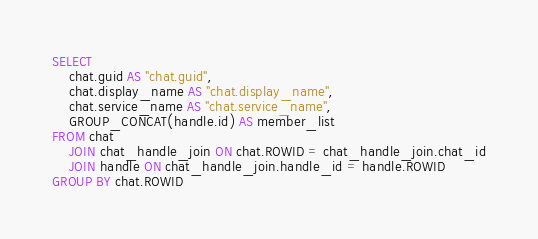Convert code to text. <code><loc_0><loc_0><loc_500><loc_500><_SQL_>SELECT
	chat.guid AS "chat.guid",
	chat.display_name AS "chat.display_name",
	chat.service_name AS "chat.service_name",
	GROUP_CONCAT(handle.id) AS member_list
FROM chat
	JOIN chat_handle_join ON chat.ROWID = chat_handle_join.chat_id
	JOIN handle ON chat_handle_join.handle_id = handle.ROWID
GROUP BY chat.ROWID
</code> 